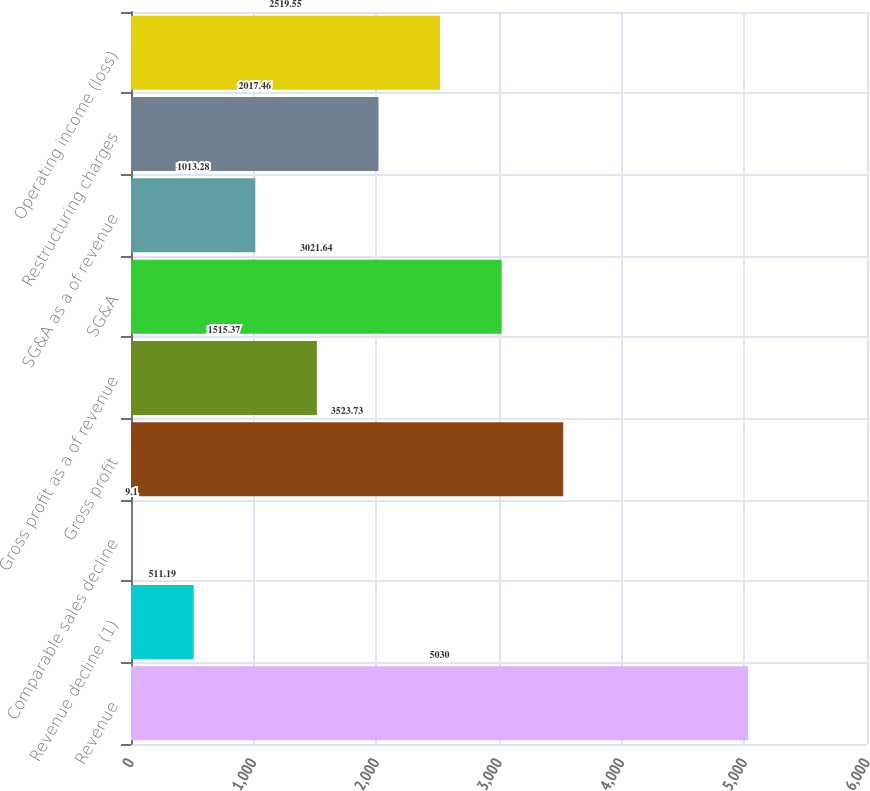Convert chart to OTSL. <chart><loc_0><loc_0><loc_500><loc_500><bar_chart><fcel>Revenue<fcel>Revenue decline (1)<fcel>Comparable sales decline<fcel>Gross profit<fcel>Gross profit as a of revenue<fcel>SG&A<fcel>SG&A as a of revenue<fcel>Restructuring charges<fcel>Operating income (loss)<nl><fcel>5030<fcel>511.19<fcel>9.1<fcel>3523.73<fcel>1515.37<fcel>3021.64<fcel>1013.28<fcel>2017.46<fcel>2519.55<nl></chart> 